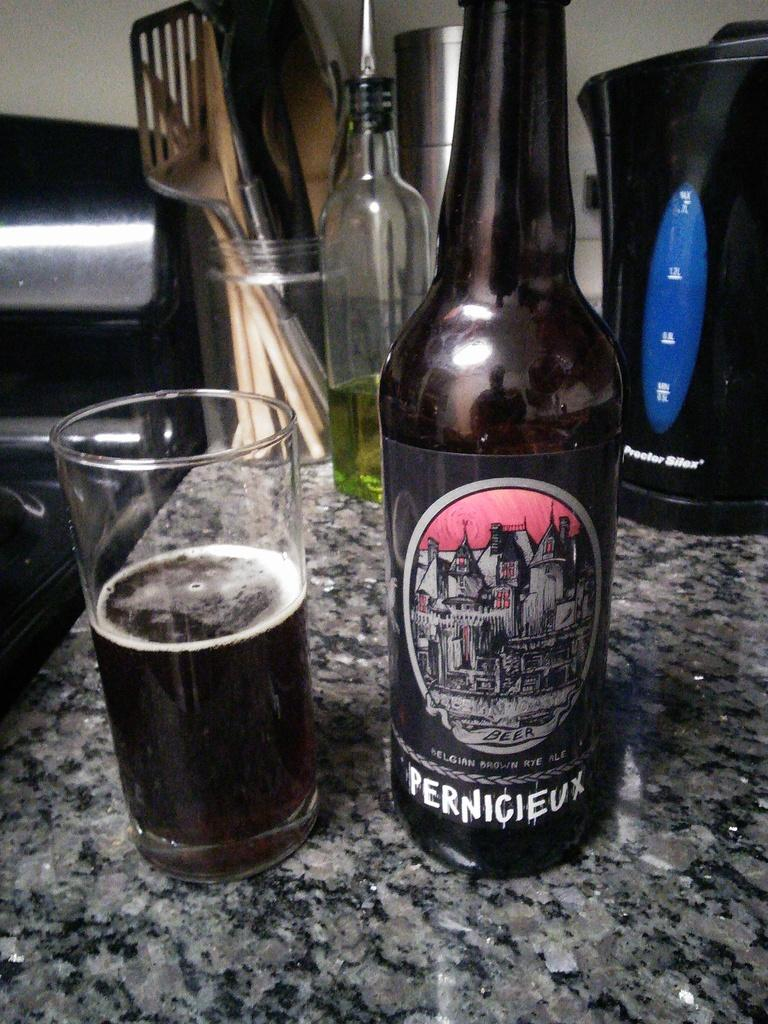Provide a one-sentence caption for the provided image. A bottle of Pernicieux sits on a stone counter along with a half-full glass. 